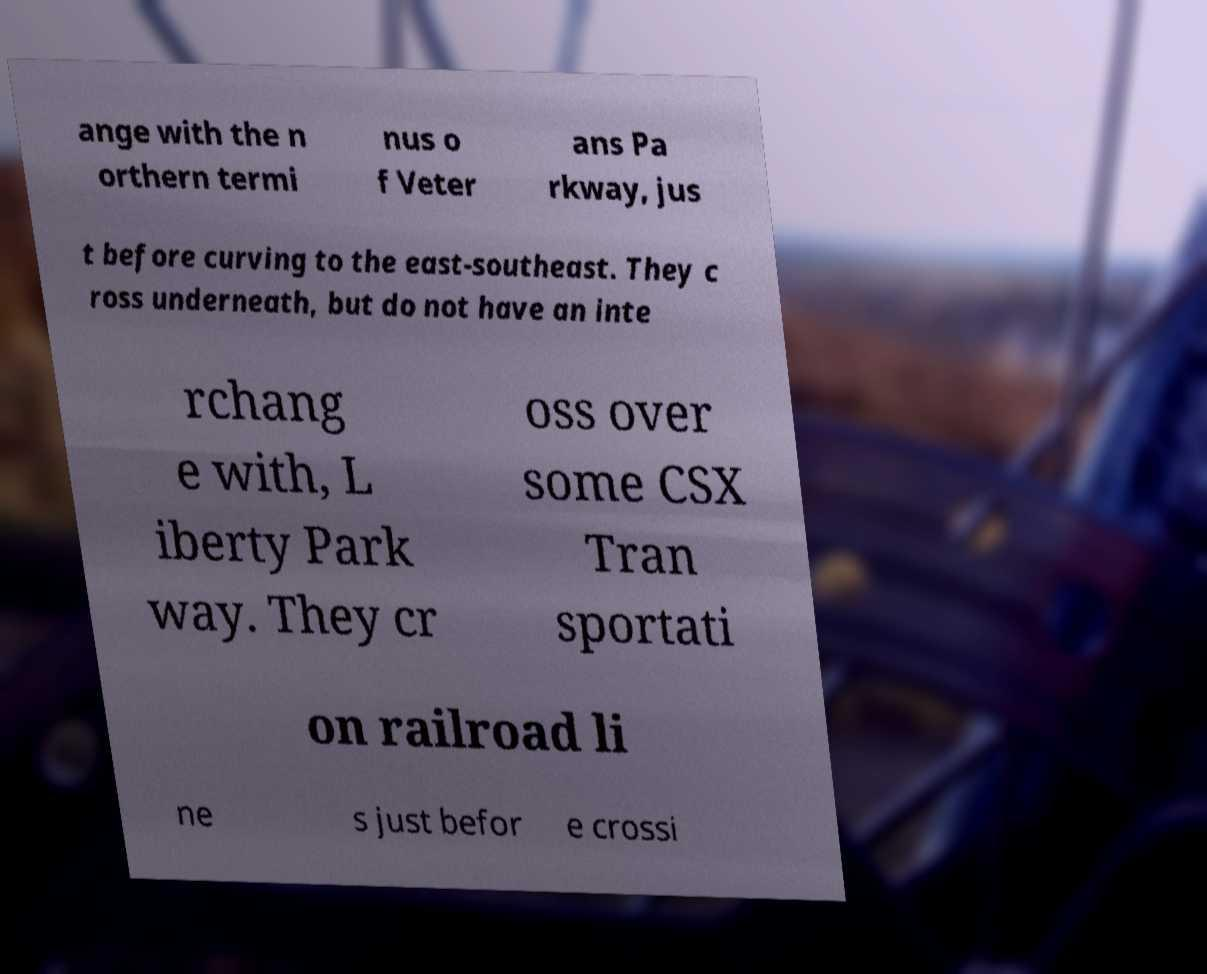What messages or text are displayed in this image? I need them in a readable, typed format. ange with the n orthern termi nus o f Veter ans Pa rkway, jus t before curving to the east-southeast. They c ross underneath, but do not have an inte rchang e with, L iberty Park way. They cr oss over some CSX Tran sportati on railroad li ne s just befor e crossi 